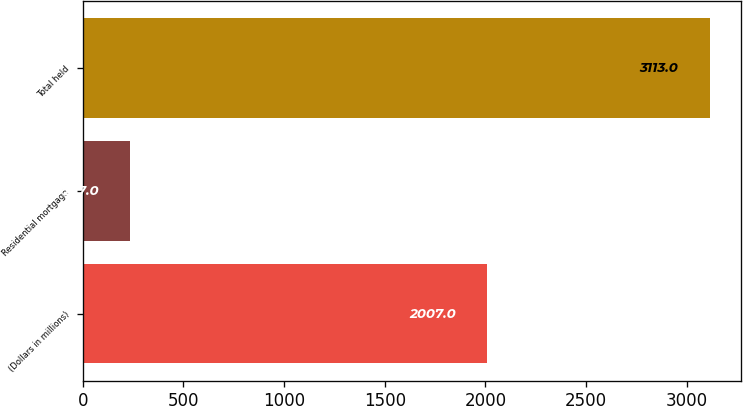<chart> <loc_0><loc_0><loc_500><loc_500><bar_chart><fcel>(Dollars in millions)<fcel>Residential mortgage<fcel>Total held<nl><fcel>2007<fcel>237<fcel>3113<nl></chart> 